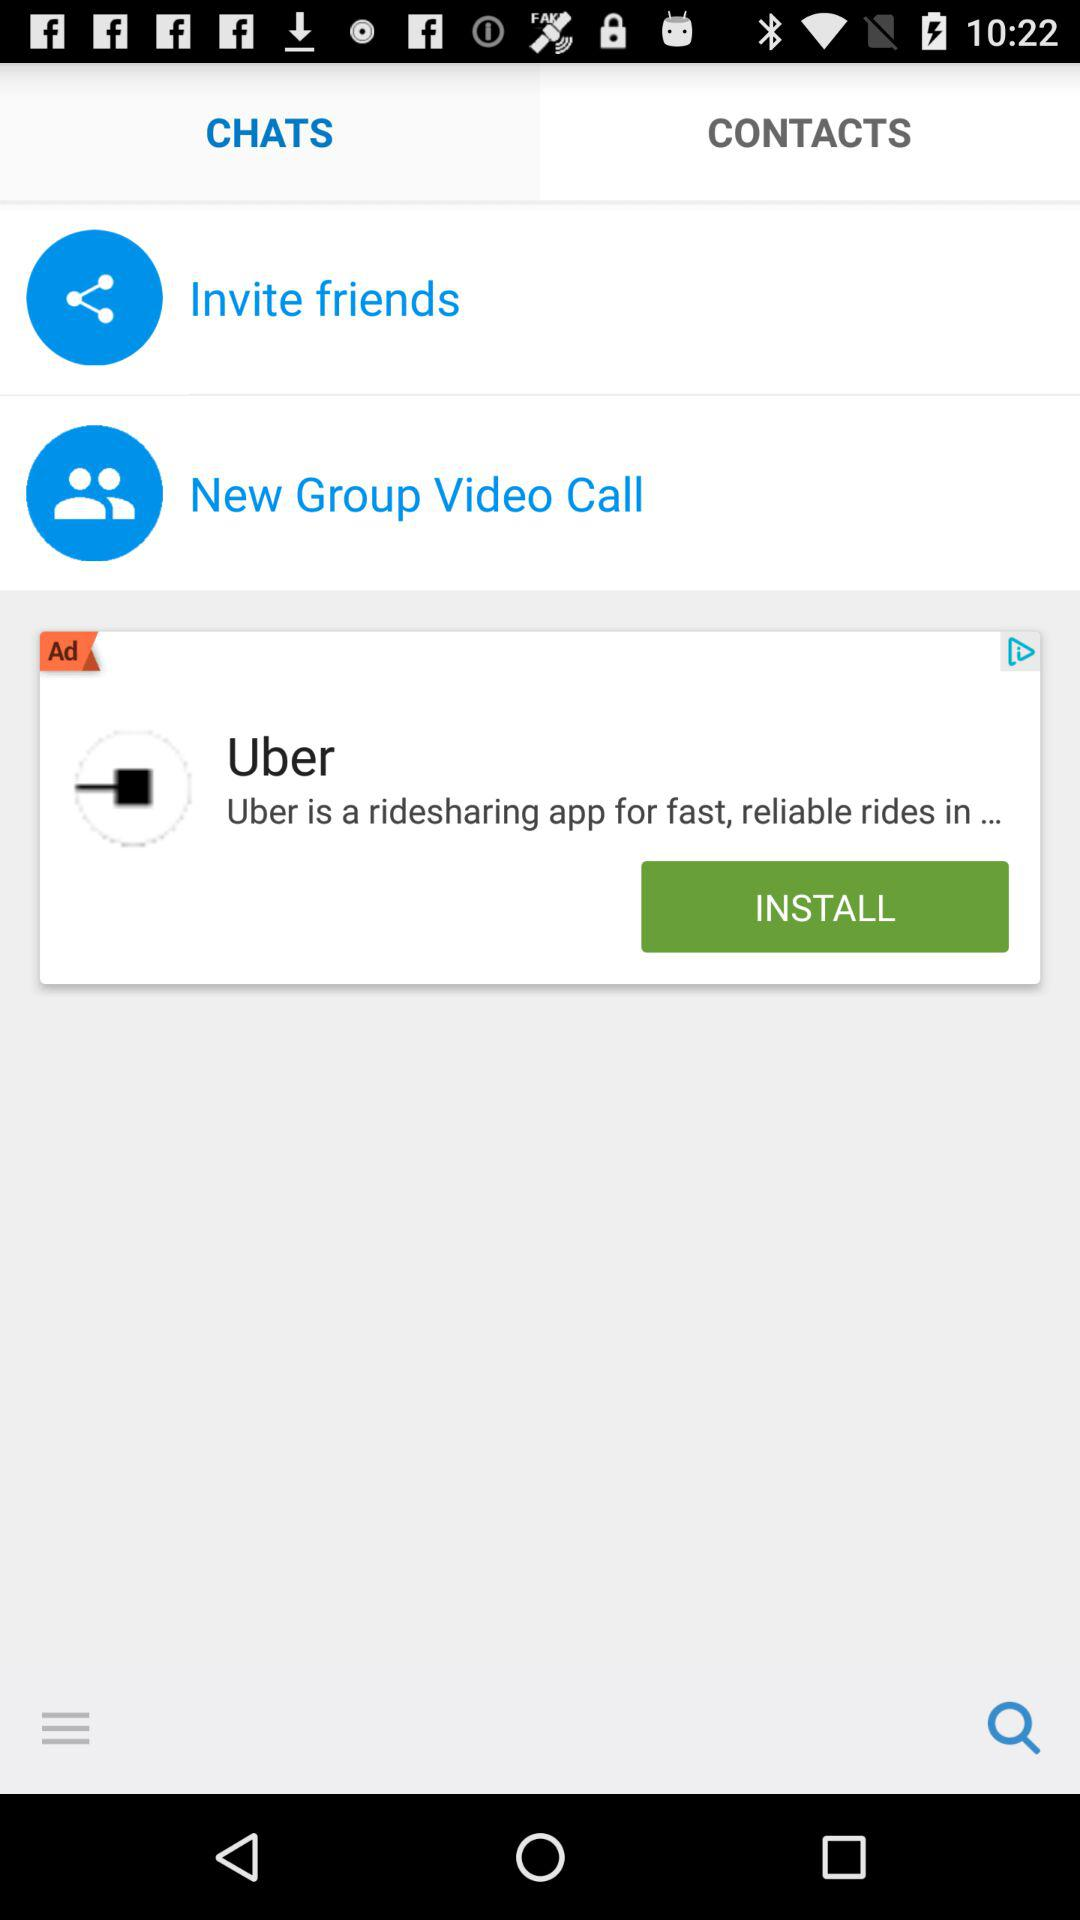Which tab am I on? You are on "CHATS" tab. 